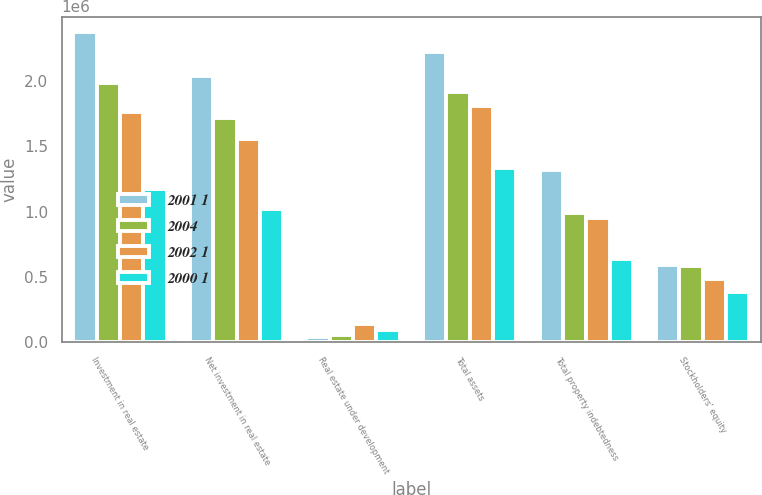Convert chart to OTSL. <chart><loc_0><loc_0><loc_500><loc_500><stacked_bar_chart><ecel><fcel>Investment in real estate<fcel>Net investment in real estate<fcel>Real estate under development<fcel>Total assets<fcel>Total property indebtedness<fcel>Stockholders' equity<nl><fcel>2001 1<fcel>2.37119e+06<fcel>2.03595e+06<fcel>38320<fcel>2.21722e+06<fcel>1.31698e+06<fcel>591277<nl><fcel>2004<fcel>1.98412e+06<fcel>1.71836e+06<fcel>55183<fcel>1.91681e+06<fcel>989045<fcel>581399<nl><fcel>2002 1<fcel>1.76222e+06<fcel>1.55421e+06<fcel>143818<fcel>1.8063e+06<fcel>949889<fcel>485691<nl><fcel>2000 1<fcel>1.1752e+06<fcel>1.01893e+06<fcel>93256<fcel>1.32946e+06<fcel>638660<fcel>381674<nl></chart> 